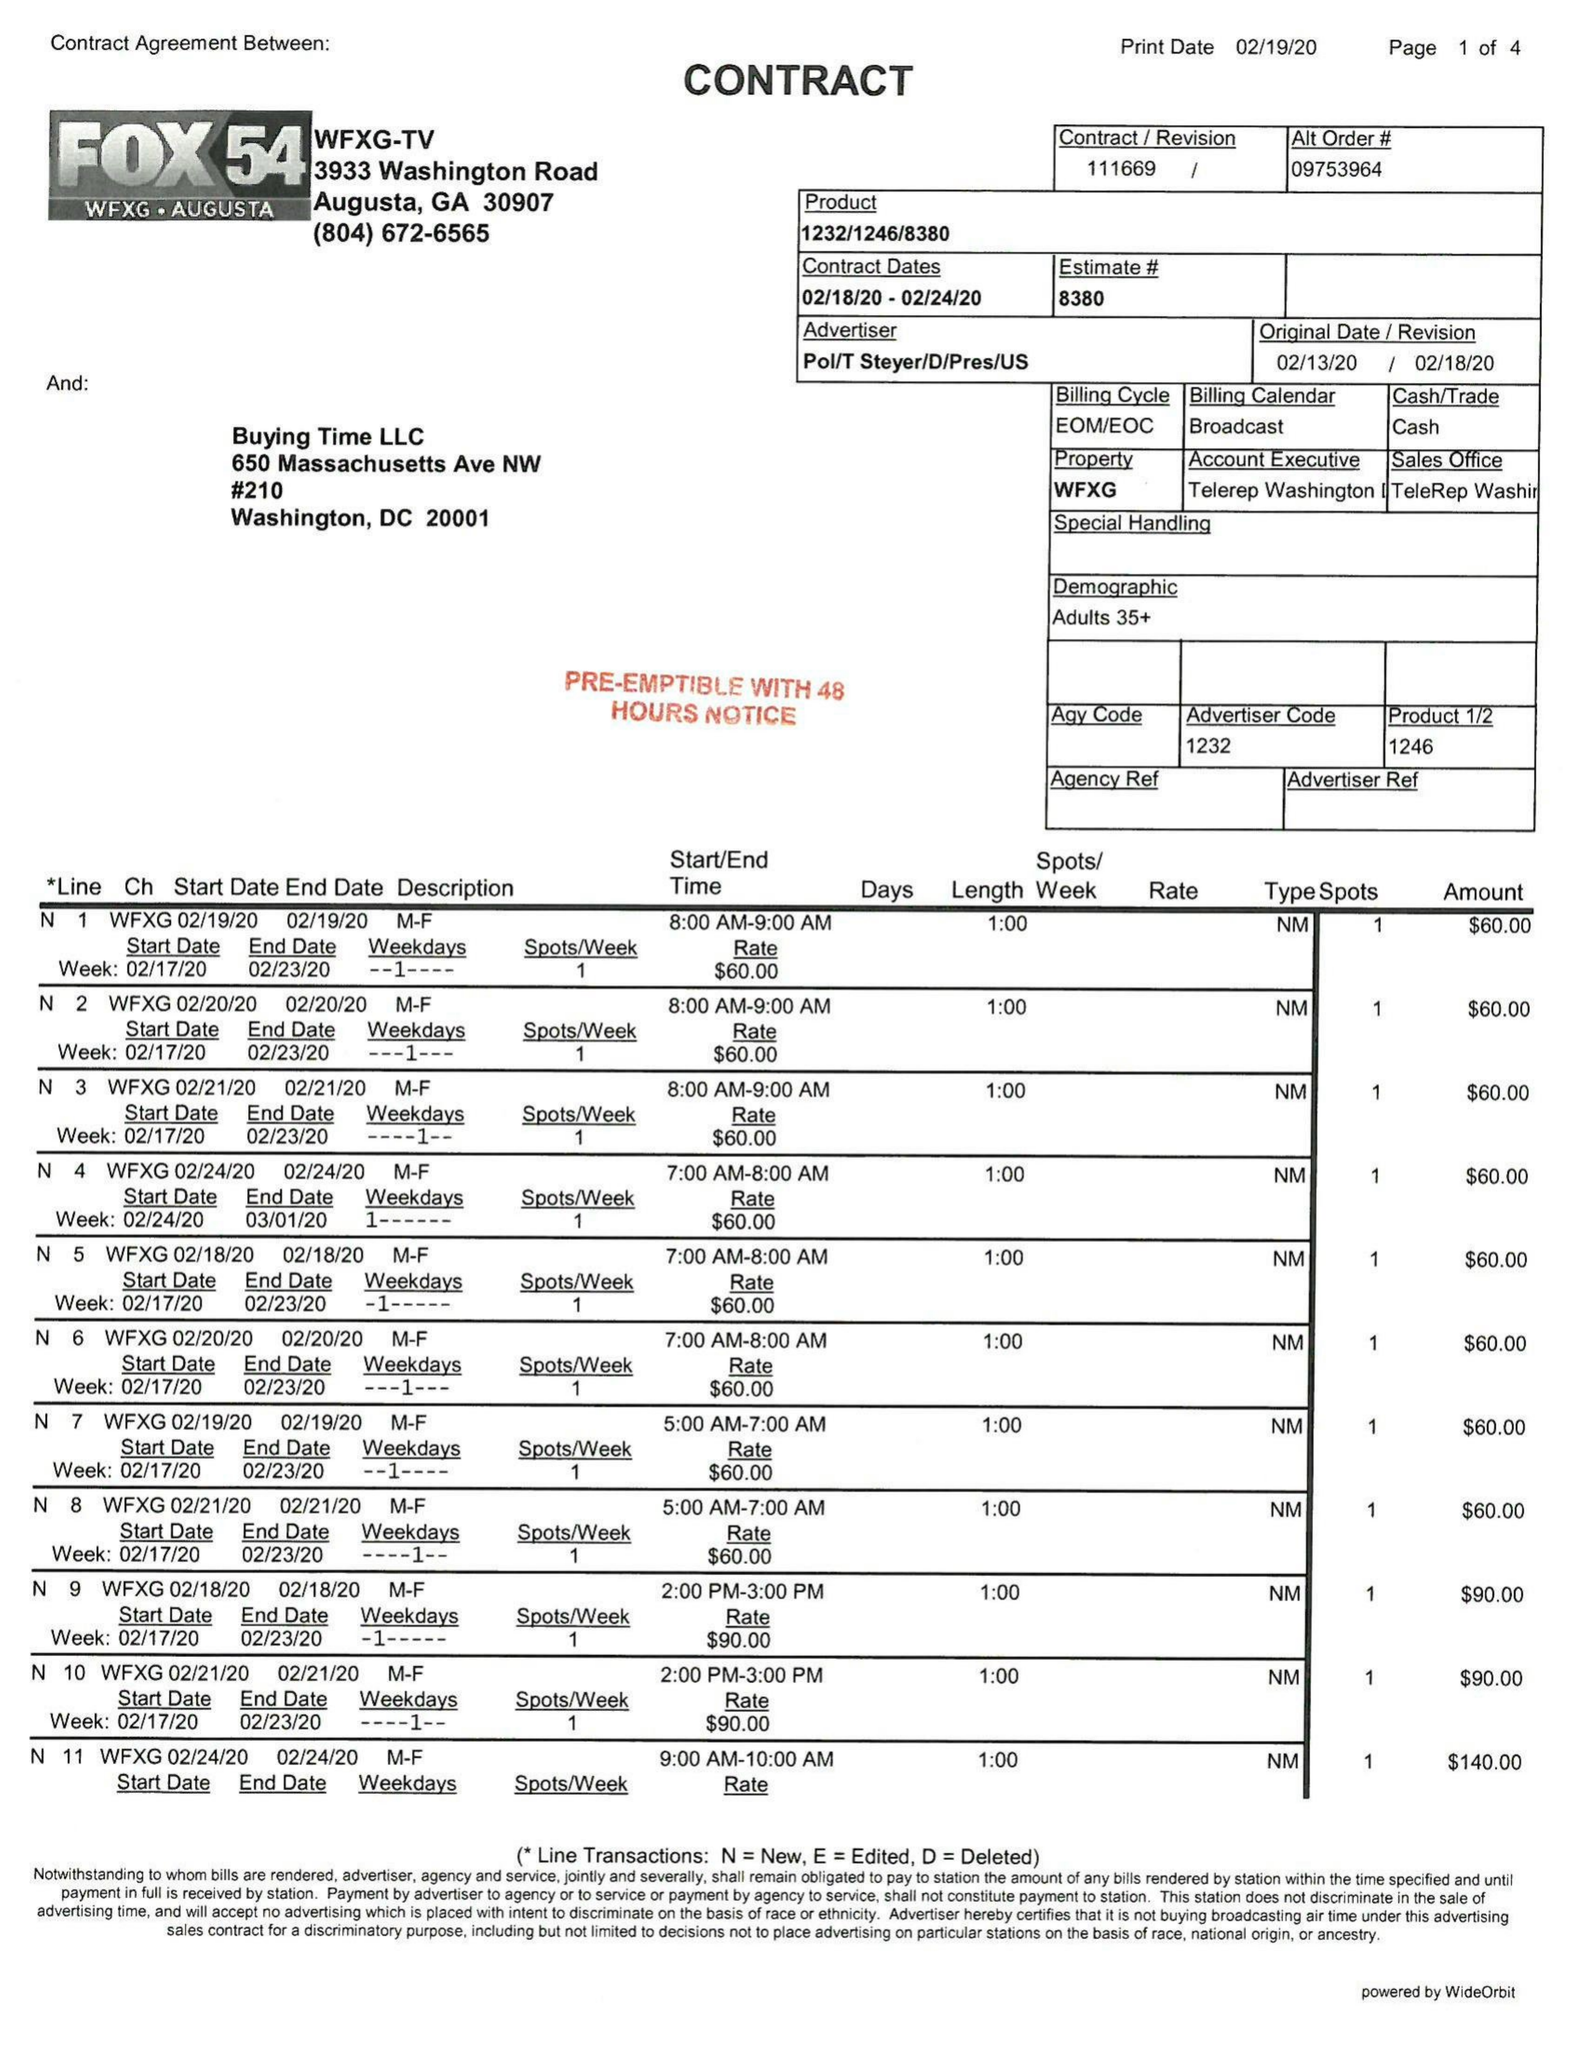What is the value for the contract_num?
Answer the question using a single word or phrase. 111669 